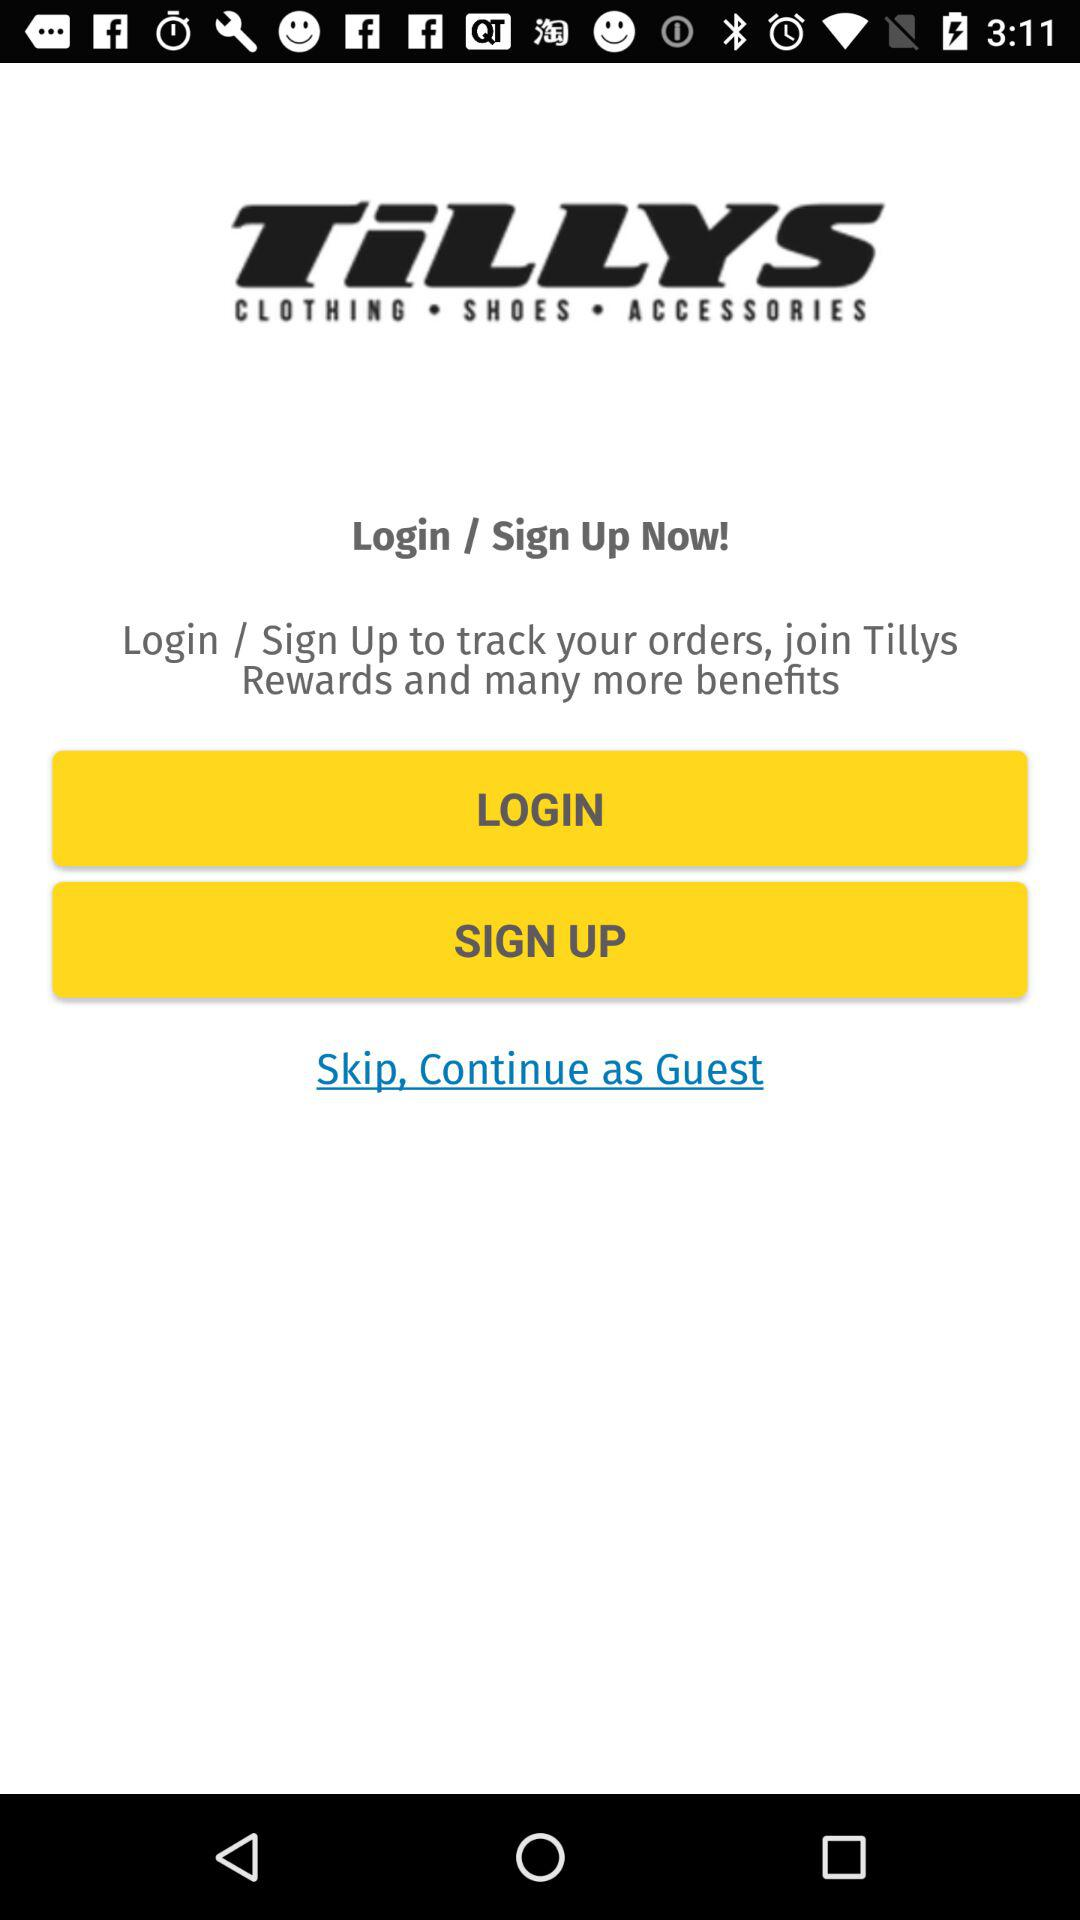Can you explain what the buttons on the application screen are for? Certainly! The 'LOGIN' button provides existing users access to their account where they can manage their details and track orders. The 'SIGN UP' button is for new customers to create an account, which enables them to collect rewards and receive updates on new products and promotions. Lastly, the 'Skip, Continue as Guest' option allows users to bypass account creation or logging in for quick access to the site's offerings without personalization. 